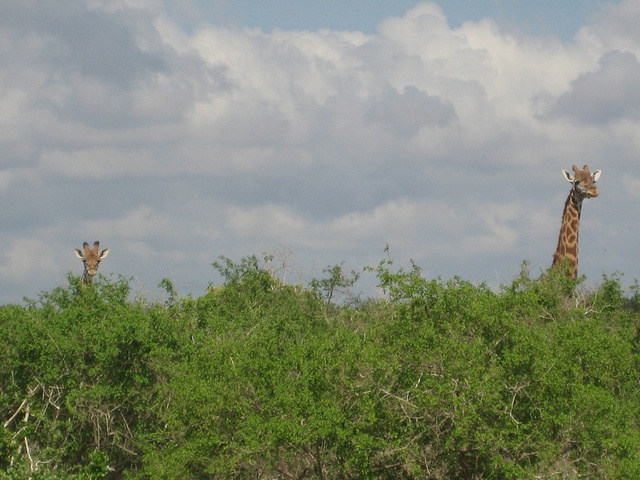Describe the objects in this image and their specific colors. I can see giraffe in darkgray, olive, and gray tones and giraffe in darkgray, gray, and darkgreen tones in this image. 